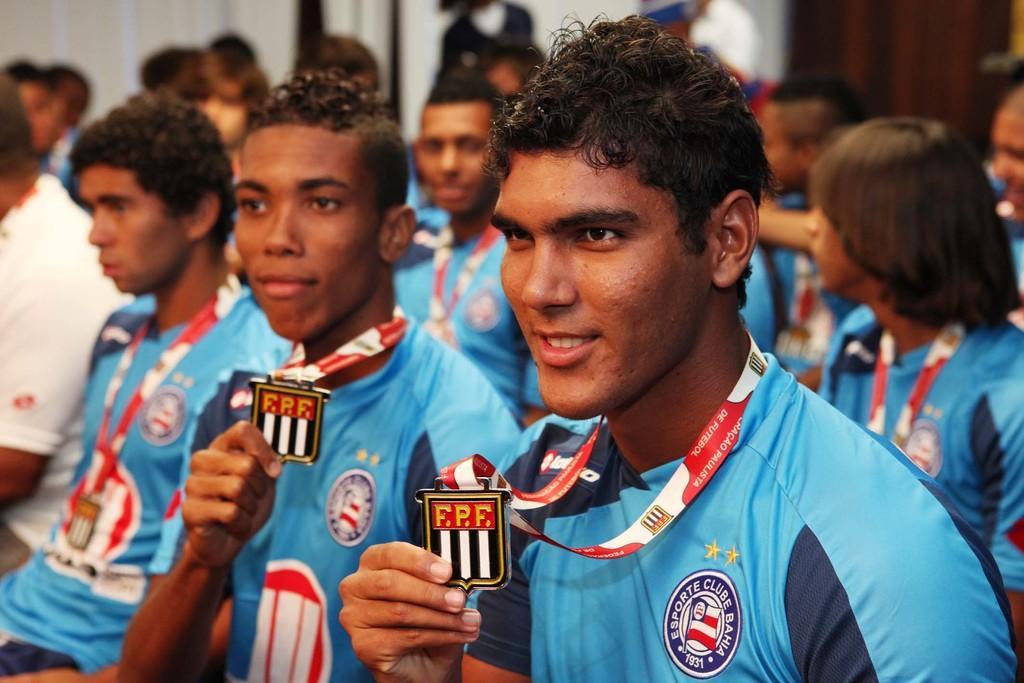In one or two sentences, can you explain what this image depicts? Here we can see people. These people wore tags. Background it is blur. 